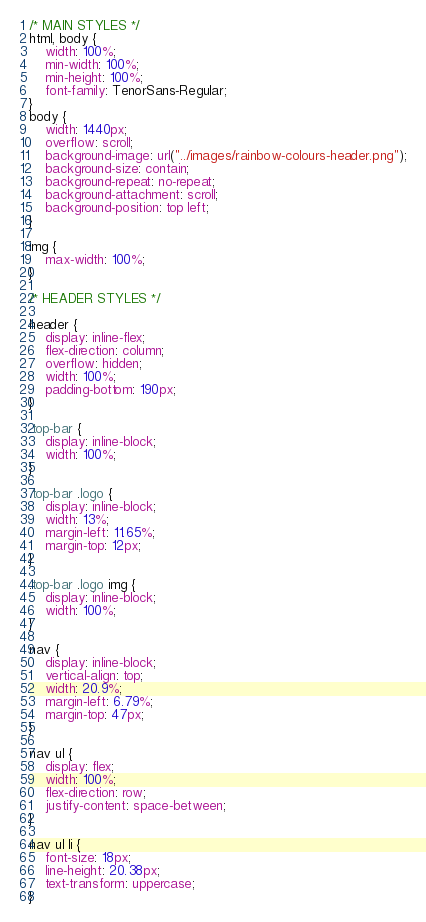<code> <loc_0><loc_0><loc_500><loc_500><_CSS_>/* MAIN STYLES */
html, body {
    width: 100%;
    min-width: 100%;
    min-height: 100%;
    font-family: TenorSans-Regular;
}
body {
    width: 1440px;
    overflow: scroll;
    background-image: url("../images/rainbow-colours-header.png");
    background-size: contain;
    background-repeat: no-repeat;
    background-attachment: scroll;
    background-position: top left;
}

img {
    max-width: 100%;
}

/* HEADER STYLES */

header {
    display: inline-flex;
    flex-direction: column;
    overflow: hidden;
    width: 100%;
    padding-bottom: 190px;
}

.top-bar {
    display: inline-block;
    width: 100%;
}

.top-bar .logo {
    display: inline-block;
    width: 13%;
    margin-left: 11.65%;
    margin-top: 12px;
}

.top-bar .logo img {
    display: inline-block;
    width: 100%;
}

nav {
    display: inline-block;
    vertical-align: top;
    width: 20.9%;
    margin-left: 6.79%;
    margin-top: 47px;
}

nav ul {
    display: flex;
    width: 100%;
    flex-direction: row;
    justify-content: space-between;
}

nav ul li {
    font-size: 18px;
    line-height: 20.38px;
    text-transform: uppercase;
}
</code> 